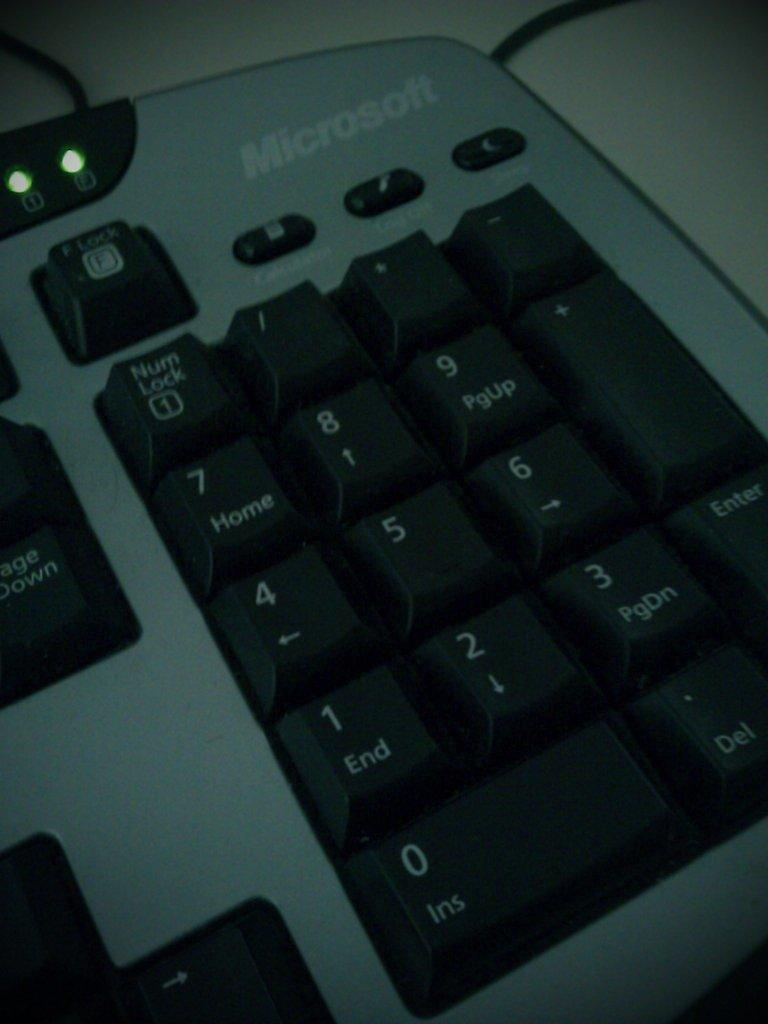What is the main object in the image? There is a keyboard in the image. Where is the keyboard located? The keyboard is on a table. What type of trail can be seen in the image? There is no trail present in the image; it only features a keyboard on a table. 